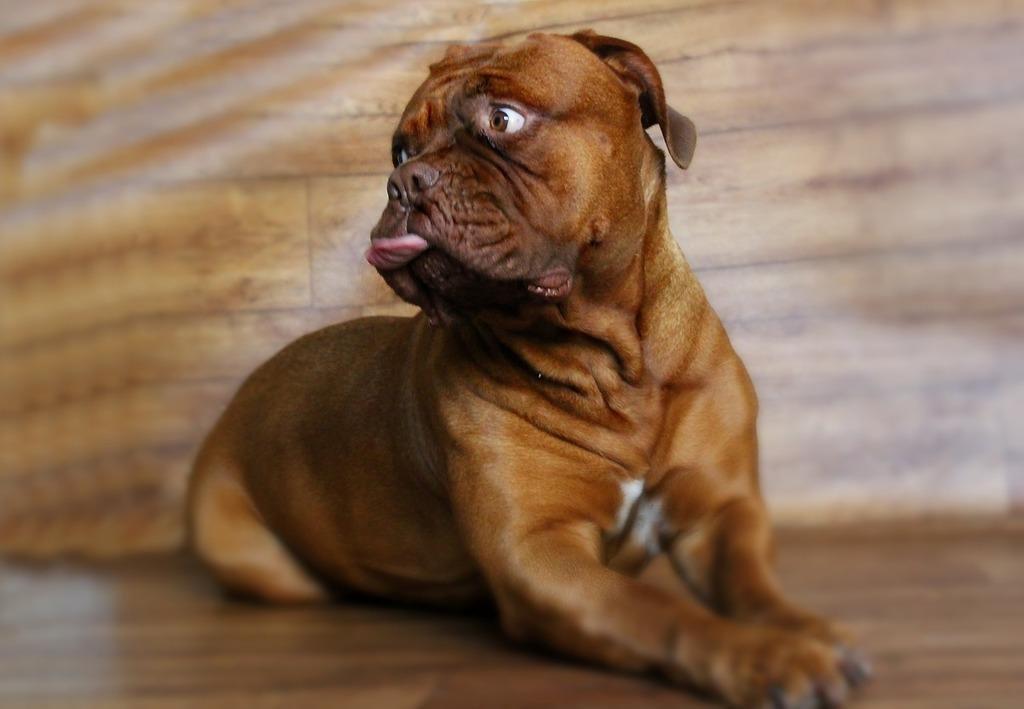What is the main subject in the middle of the image? There is a dog in the middle of the image. What is the surface that the dog is standing on? There is a floor at the bottom of the image. What can be seen behind the dog in the image? There is a wall in the background of the image. How many eggs are visible on the wall in the image? There are no eggs present in the image; only a dog and a wall are visible. What type of beetle can be seen crawling on the floor in the image? There is no beetle present in the image; only a dog and a floor are visible. 